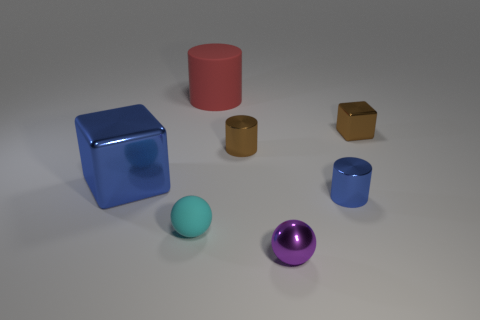Subtract all red cylinders. How many cylinders are left? 2 Subtract 1 blocks. How many blocks are left? 1 Add 3 matte cylinders. How many objects exist? 10 Subtract all blue cylinders. How many cylinders are left? 2 Add 5 matte spheres. How many matte spheres are left? 6 Add 1 small purple metal objects. How many small purple metal objects exist? 2 Subtract 0 red cubes. How many objects are left? 7 Subtract all cylinders. How many objects are left? 4 Subtract all purple spheres. Subtract all blue blocks. How many spheres are left? 1 Subtract all blue blocks. How many brown cylinders are left? 1 